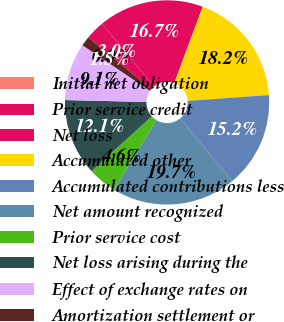<chart> <loc_0><loc_0><loc_500><loc_500><pie_chart><fcel>Initial net obligation<fcel>Prior service credit<fcel>Net loss<fcel>Accumulated other<fcel>Accumulated contributions less<fcel>Net amount recognized<fcel>Prior service cost<fcel>Net loss arising during the<fcel>Effect of exchange rates on<fcel>Amortization settlement or<nl><fcel>0.0%<fcel>3.03%<fcel>16.66%<fcel>18.18%<fcel>15.15%<fcel>19.69%<fcel>4.55%<fcel>12.12%<fcel>9.09%<fcel>1.52%<nl></chart> 